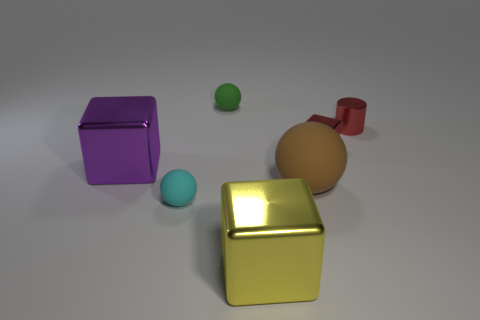Subtract all large brown balls. How many balls are left? 2 Subtract 1 blocks. How many blocks are left? 2 Subtract all blue balls. Subtract all red blocks. How many balls are left? 3 Add 1 large metal objects. How many objects exist? 8 Add 4 blue objects. How many blue objects exist? 4 Subtract 1 cyan balls. How many objects are left? 6 Subtract all spheres. How many objects are left? 4 Subtract all small red cylinders. Subtract all tiny matte spheres. How many objects are left? 4 Add 2 large brown matte objects. How many large brown matte objects are left? 3 